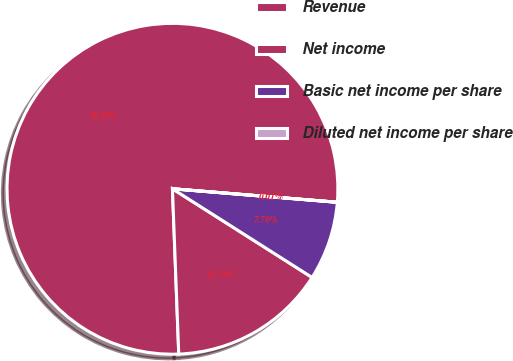<chart> <loc_0><loc_0><loc_500><loc_500><pie_chart><fcel>Revenue<fcel>Net income<fcel>Basic net income per share<fcel>Diluted net income per share<nl><fcel>76.91%<fcel>15.39%<fcel>7.7%<fcel>0.01%<nl></chart> 